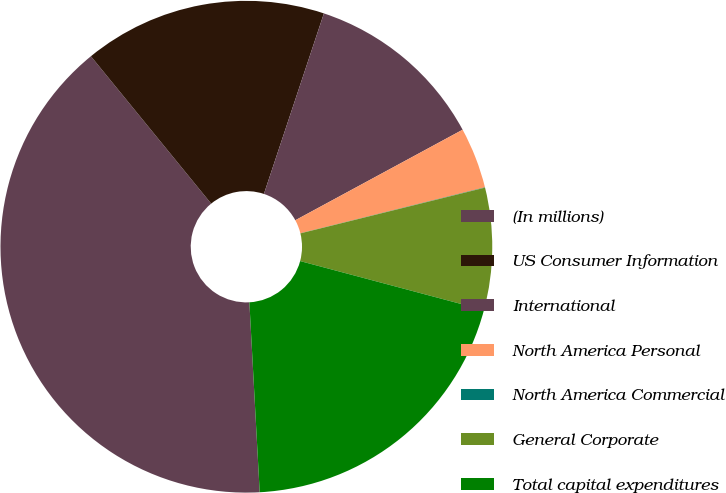<chart> <loc_0><loc_0><loc_500><loc_500><pie_chart><fcel>(In millions)<fcel>US Consumer Information<fcel>International<fcel>North America Personal<fcel>North America Commercial<fcel>General Corporate<fcel>Total capital expenditures<nl><fcel>39.97%<fcel>16.0%<fcel>12.0%<fcel>4.01%<fcel>0.02%<fcel>8.01%<fcel>19.99%<nl></chart> 